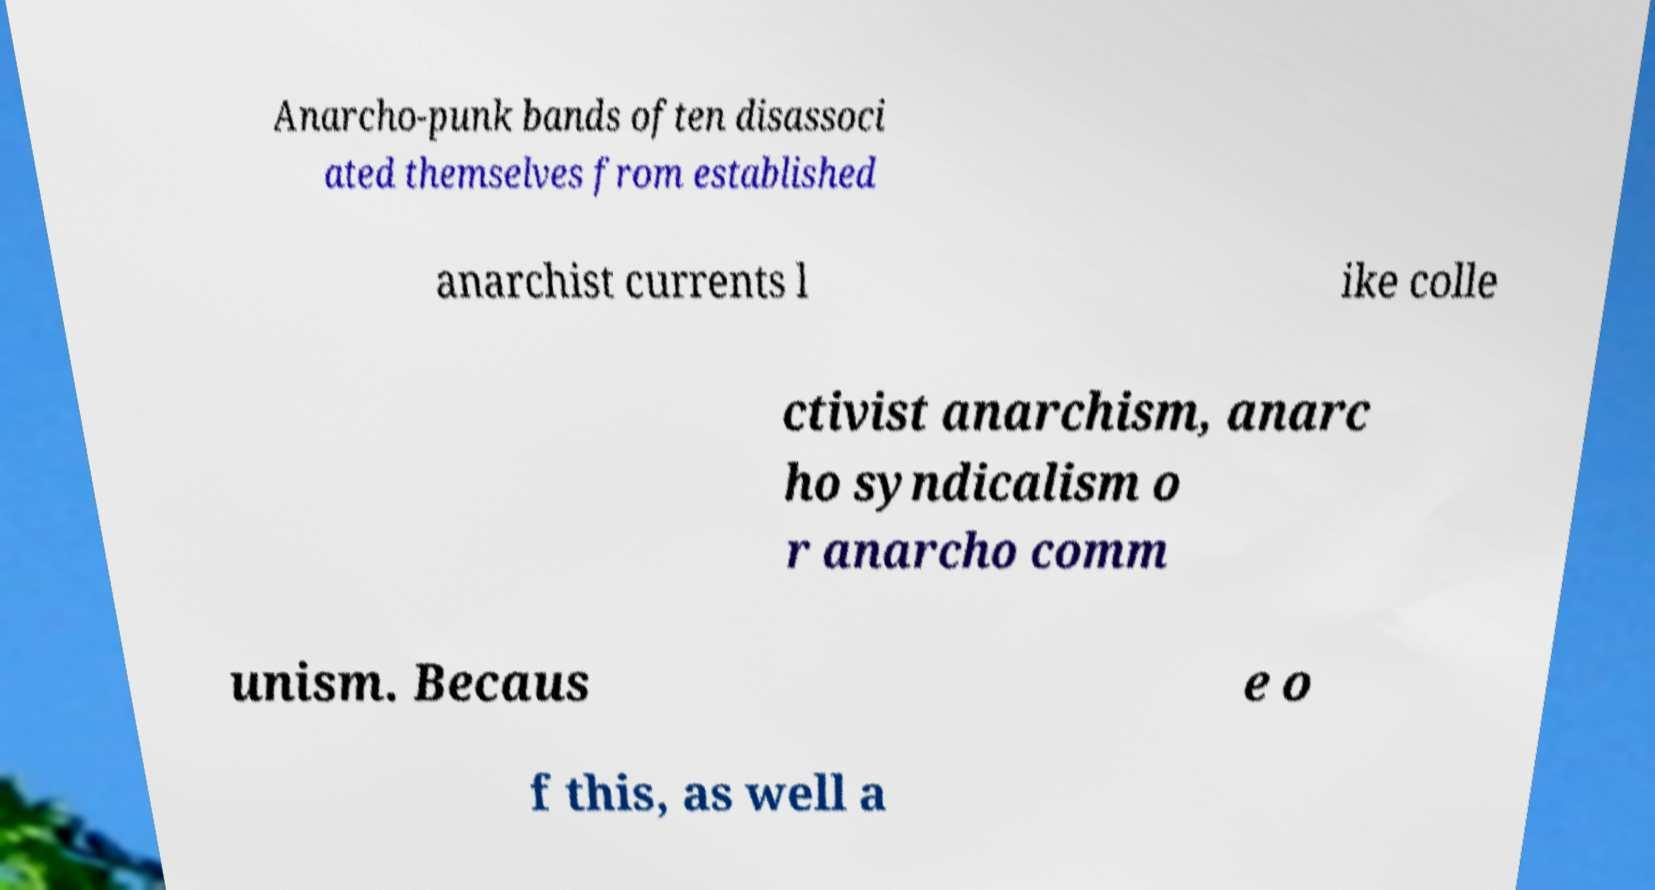Please identify and transcribe the text found in this image. Anarcho-punk bands often disassoci ated themselves from established anarchist currents l ike colle ctivist anarchism, anarc ho syndicalism o r anarcho comm unism. Becaus e o f this, as well a 